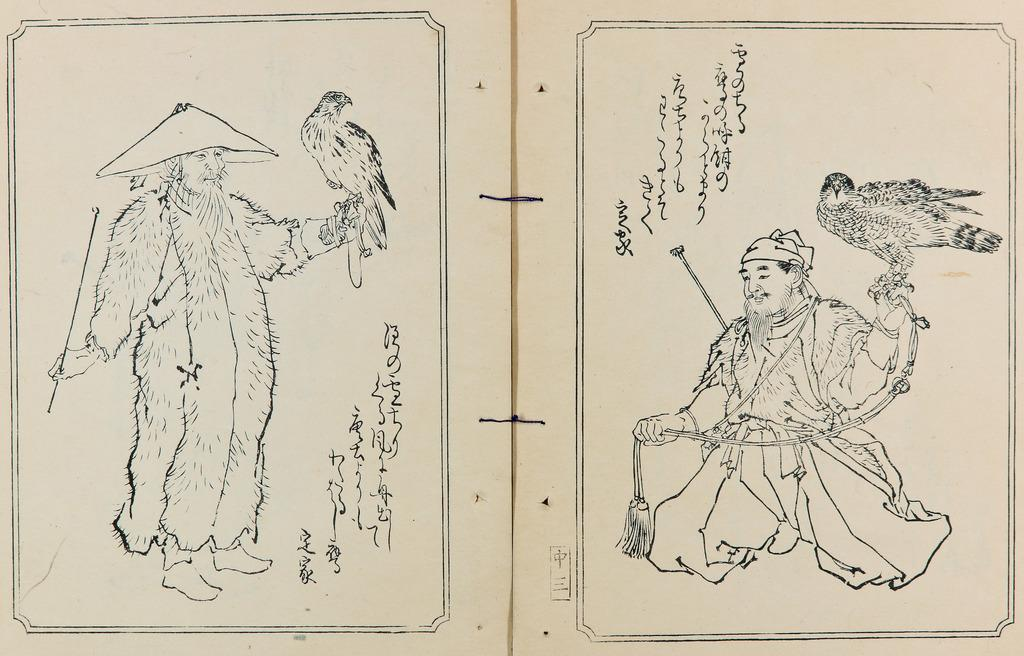Who is present in the image? There is a man in the image. What is the man holding in his hand? The man is holding a bird in his hand. What else can be seen in the image besides the man and the bird? There are pages with text in the image. Can you tell me how deep the river is in the image? There is no river present in the image; it features a man holding a bird and pages with text. 